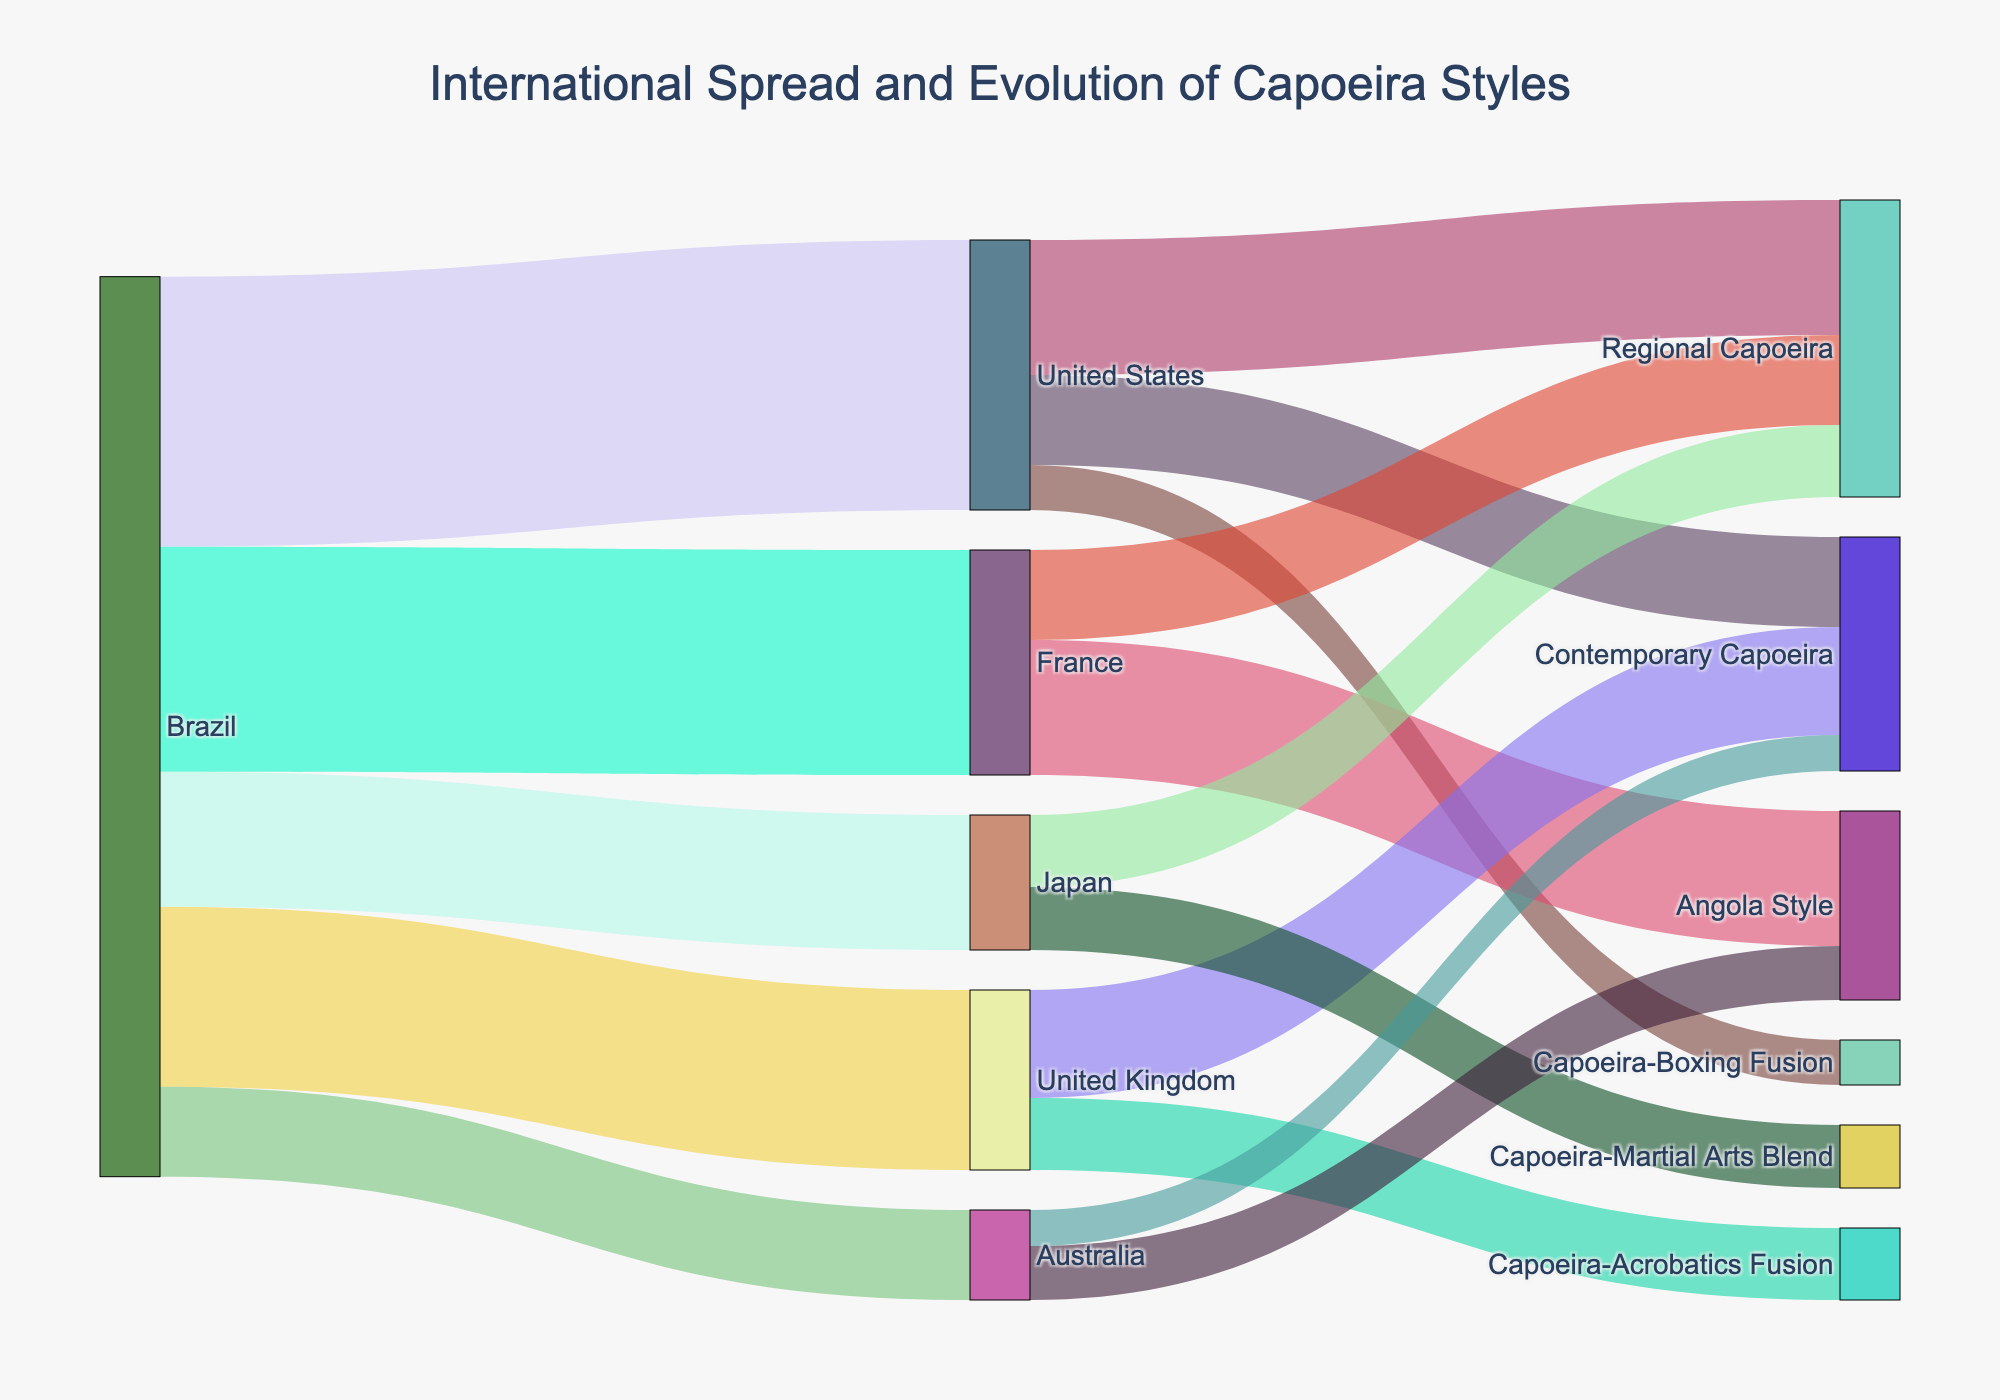What is the title of the figure? The figure's title is usually prominently displayed at the top of the plot. Here, it is "International Spread and Evolution of Capoeira Styles," which directly describes what the diagram is about.
Answer: International Spread and Evolution of Capoeira Styles Which country has the highest number of Capoeira practitioners spreading out internationally? By looking at the source nodes and the values flowing out from them, Brazil has the highest total value with flows of 30 (to the United States), 25 (to France), 20 (to the United Kingdom), 15 (to Japan), and 10 (to Australia). Summed up, Brazil has 100 practitioners spreading out.
Answer: Brazil What is the total number of Capoeira practitioners spreading from Brazil to Europe (United Kingdom and France)? By adding the values from Brazil to the United Kingdom (20) and France (25), the total number of practitioners spreading from Brazil to Europe is calculated as 20 + 25.
Answer: 45 Which country has the smallest number of Capoeira practitioners represented in the Sankey Diagram? The flows from Brazil show that Australia has the smallest number, with a value of 10 practitioners.
Answer: Australia What is the combined value of Capoeira styles within the United States? Summing up the values for the United States spreading to different styles: Regional Capoeira (15), Contemporary Capoeira (10), and Capoeira-Boxing Fusion (5) gives us a total of 30.
Answer: 30 Compare the number of practitioners practicing Regional Capoeira in the United States and Japan. By looking at the links, the United States has 15 practitioners for Regional Capoeira, while Japan has 8 practitioners. This shows that the United States has more practitioners in this style.
Answer: The United States has more Which type of Capoeira has the most practitioners in France and what is the value? By checking the links from France, Angola Style has the highest value with 15 practitioners.
Answer: Angola Style, 15 How many more practitioners practice Contemporary Capoeira in the United Kingdom compared to Australia? Contemporary Capoeira in the United Kingdom has 12 practitioners, while Australia has 4 practitioners. The difference is calculated as 12 - 4.
Answer: 8 What unique Capoeira styles have emerged in the United Kingdom and Japan? The new blends are identified by checking the target categories: the United Kingdom has Capoeira-Acrobatics Fusion (8), and Japan has Capoeira-Martial Arts Blend (7).
Answer: Capoeira-Acrobatics Fusion and Capoeira-Martial Arts Blend Which Capoeira style has the smallest value in the diagram, and what is that value? By inspecting the lowest values among the links, Australia's link to Contemporary Capoeira has the smallest value of 4.
Answer: Contemporary Capoeira in Australia, 4 